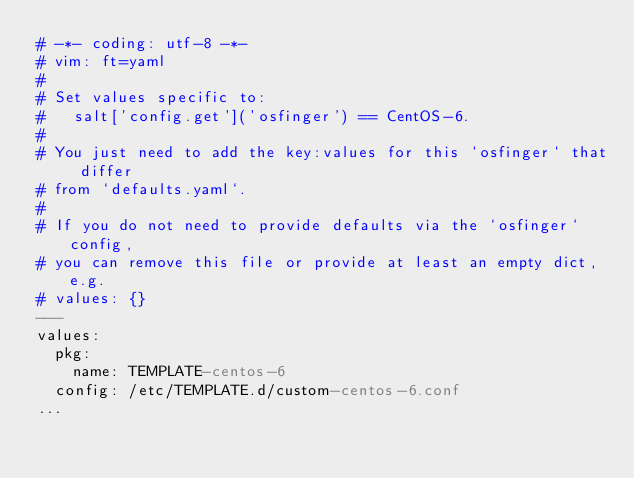<code> <loc_0><loc_0><loc_500><loc_500><_YAML_># -*- coding: utf-8 -*-
# vim: ft=yaml
#
# Set values specific to:
#   salt['config.get']('osfinger') == CentOS-6.
#
# You just need to add the key:values for this `osfinger` that differ
# from `defaults.yaml`.
#
# If you do not need to provide defaults via the `osfinger` config,
# you can remove this file or provide at least an empty dict, e.g.
# values: {}
---
values:
  pkg:
    name: TEMPLATE-centos-6
  config: /etc/TEMPLATE.d/custom-centos-6.conf
...
</code> 